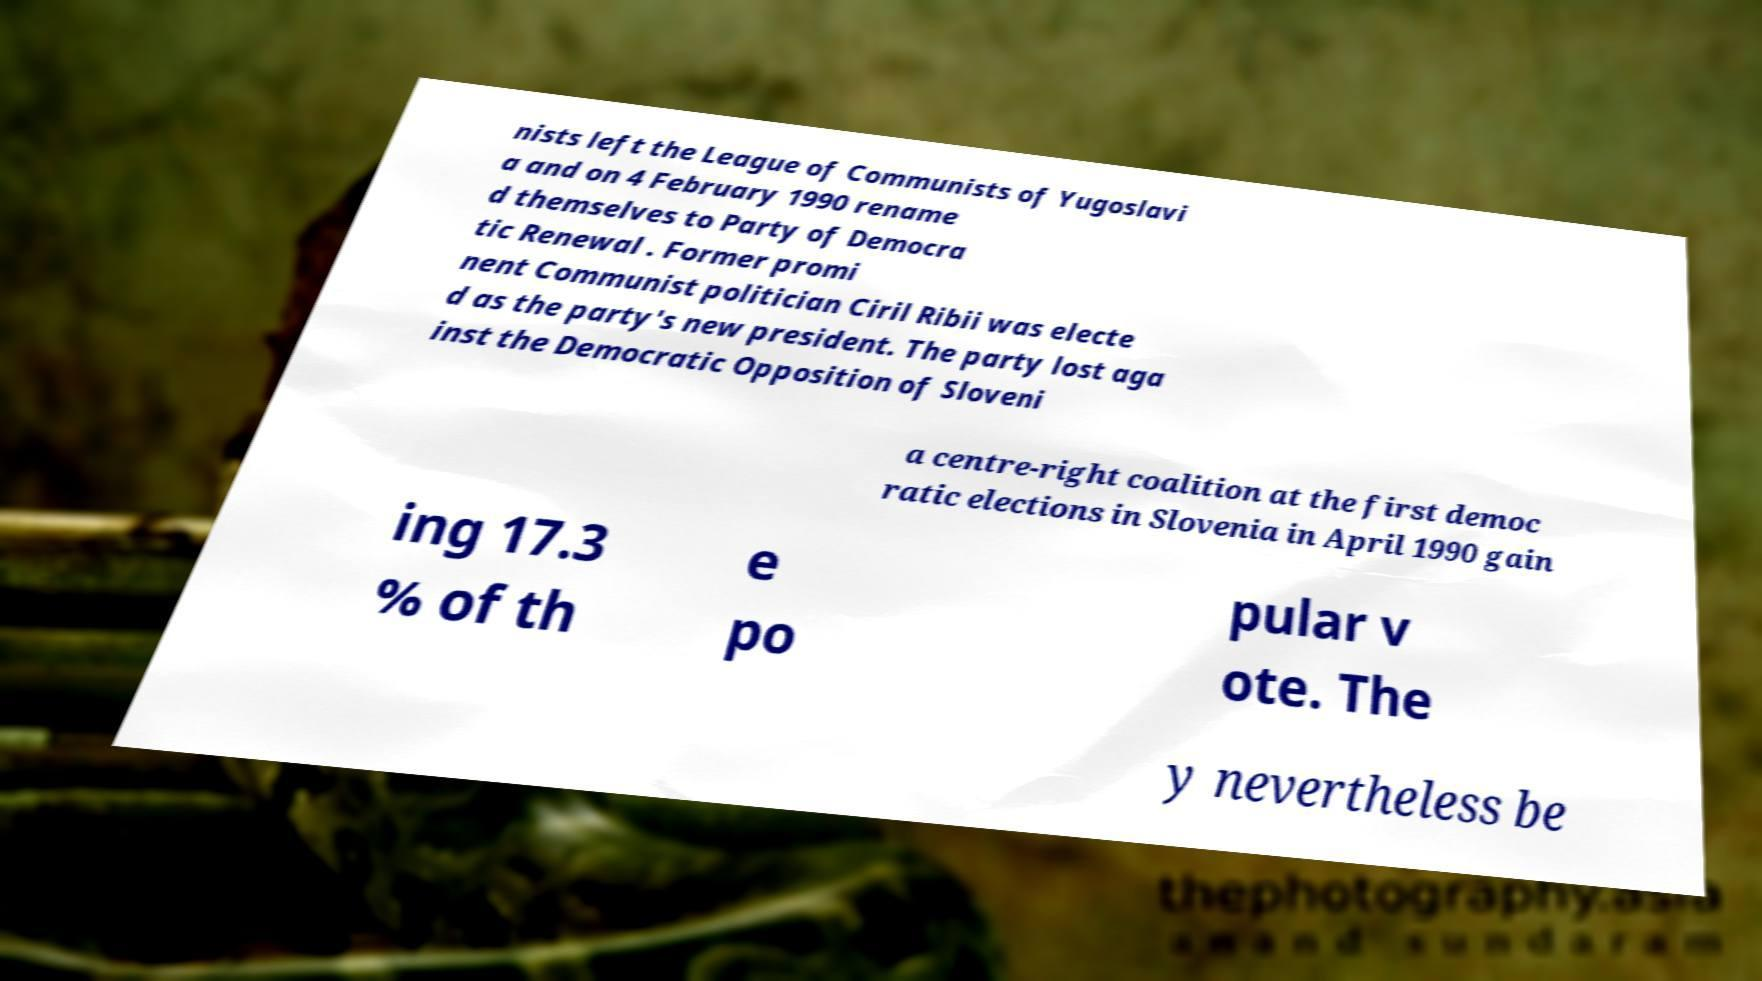What messages or text are displayed in this image? I need them in a readable, typed format. nists left the League of Communists of Yugoslavi a and on 4 February 1990 rename d themselves to Party of Democra tic Renewal . Former promi nent Communist politician Ciril Ribii was electe d as the party's new president. The party lost aga inst the Democratic Opposition of Sloveni a centre-right coalition at the first democ ratic elections in Slovenia in April 1990 gain ing 17.3 % of th e po pular v ote. The y nevertheless be 